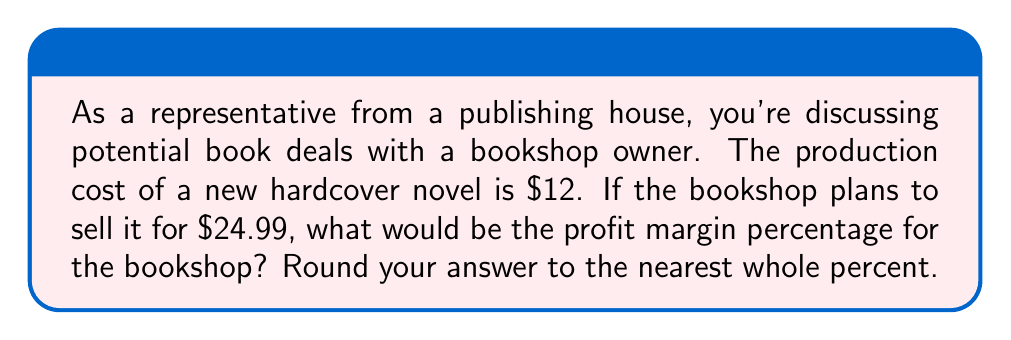Can you answer this question? To calculate the profit margin percentage, we need to follow these steps:

1. Calculate the profit:
   Profit = Selling Price - Cost
   $$ \text{Profit} = $24.99 - $12 = $12.99 $$

2. Calculate the profit margin:
   Profit Margin = Profit ÷ Selling Price
   $$ \text{Profit Margin} = \frac{$12.99}{$24.99} \approx 0.5198 $$

3. Convert the profit margin to a percentage:
   Profit Margin Percentage = Profit Margin × 100%
   $$ \text{Profit Margin Percentage} = 0.5198 \times 100\% \approx 51.98\% $$

4. Round to the nearest whole percent:
   $$ 51.98\% \approx 52\% $$

Therefore, the profit margin percentage for the bookshop would be 52%.
Answer: 52% 